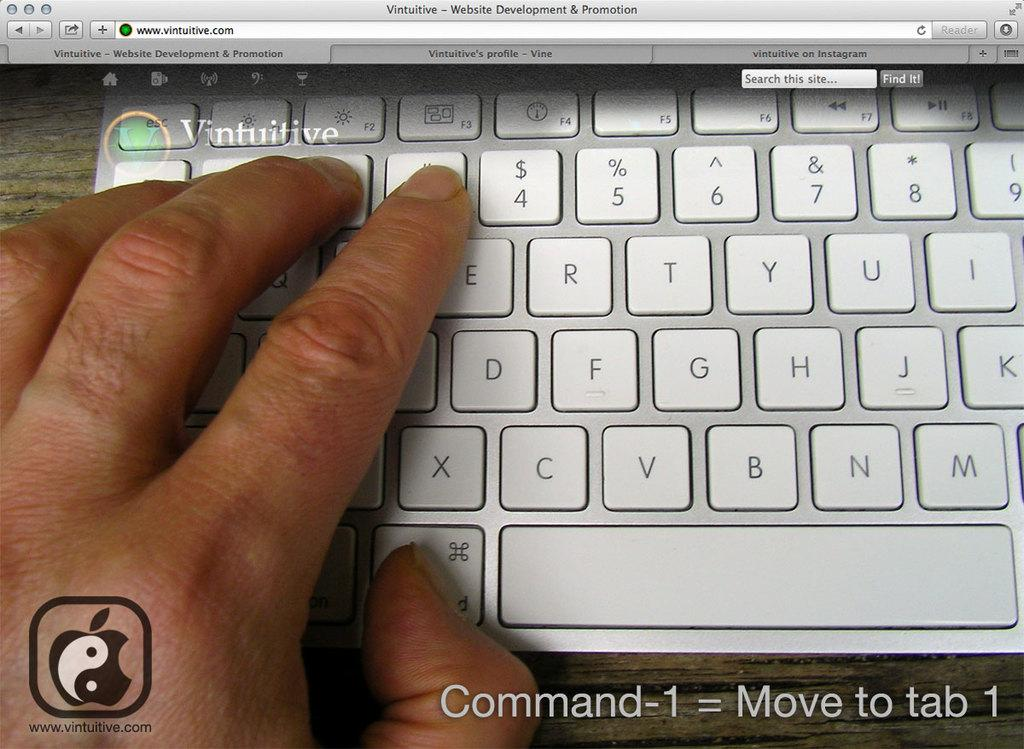Provide a one-sentence caption for the provided image. a website for vintuitive has a keyboard on the screen. 